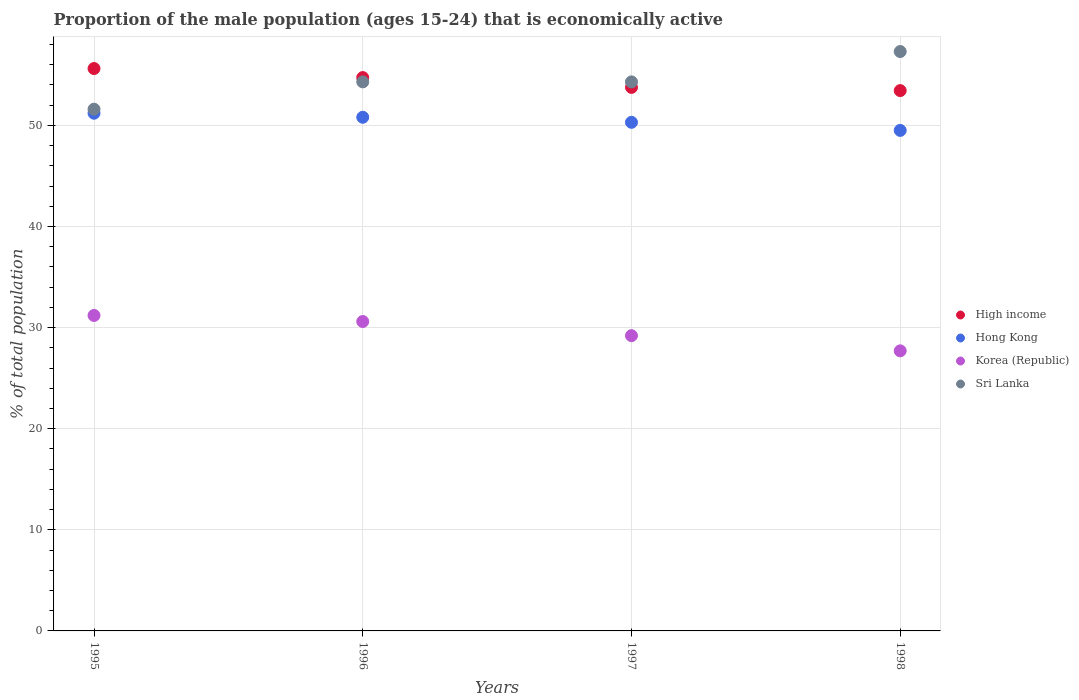What is the proportion of the male population that is economically active in Hong Kong in 1995?
Your response must be concise. 51.2. Across all years, what is the maximum proportion of the male population that is economically active in Sri Lanka?
Offer a terse response. 57.3. Across all years, what is the minimum proportion of the male population that is economically active in Sri Lanka?
Ensure brevity in your answer.  51.6. In which year was the proportion of the male population that is economically active in High income maximum?
Your answer should be very brief. 1995. What is the total proportion of the male population that is economically active in Korea (Republic) in the graph?
Your answer should be very brief. 118.7. What is the difference between the proportion of the male population that is economically active in Hong Kong in 1995 and that in 1998?
Your response must be concise. 1.7. What is the difference between the proportion of the male population that is economically active in Sri Lanka in 1998 and the proportion of the male population that is economically active in Korea (Republic) in 1996?
Your answer should be compact. 26.7. What is the average proportion of the male population that is economically active in Korea (Republic) per year?
Give a very brief answer. 29.68. In the year 1996, what is the difference between the proportion of the male population that is economically active in Korea (Republic) and proportion of the male population that is economically active in Hong Kong?
Offer a terse response. -20.2. In how many years, is the proportion of the male population that is economically active in Korea (Republic) greater than 34 %?
Make the answer very short. 0. What is the ratio of the proportion of the male population that is economically active in Korea (Republic) in 1997 to that in 1998?
Provide a short and direct response. 1.05. Is the proportion of the male population that is economically active in Korea (Republic) in 1995 less than that in 1998?
Offer a terse response. No. What is the difference between the highest and the second highest proportion of the male population that is economically active in High income?
Keep it short and to the point. 0.89. What is the difference between the highest and the lowest proportion of the male population that is economically active in Hong Kong?
Provide a short and direct response. 1.7. In how many years, is the proportion of the male population that is economically active in Hong Kong greater than the average proportion of the male population that is economically active in Hong Kong taken over all years?
Your answer should be compact. 2. Is the sum of the proportion of the male population that is economically active in Korea (Republic) in 1995 and 1996 greater than the maximum proportion of the male population that is economically active in High income across all years?
Offer a very short reply. Yes. Is it the case that in every year, the sum of the proportion of the male population that is economically active in Sri Lanka and proportion of the male population that is economically active in Hong Kong  is greater than the sum of proportion of the male population that is economically active in High income and proportion of the male population that is economically active in Korea (Republic)?
Your answer should be very brief. Yes. Is it the case that in every year, the sum of the proportion of the male population that is economically active in High income and proportion of the male population that is economically active in Sri Lanka  is greater than the proportion of the male population that is economically active in Korea (Republic)?
Offer a terse response. Yes. How many years are there in the graph?
Make the answer very short. 4. What is the difference between two consecutive major ticks on the Y-axis?
Provide a short and direct response. 10. Does the graph contain any zero values?
Offer a terse response. No. Where does the legend appear in the graph?
Offer a terse response. Center right. How many legend labels are there?
Keep it short and to the point. 4. What is the title of the graph?
Give a very brief answer. Proportion of the male population (ages 15-24) that is economically active. What is the label or title of the X-axis?
Offer a very short reply. Years. What is the label or title of the Y-axis?
Your answer should be very brief. % of total population. What is the % of total population of High income in 1995?
Your response must be concise. 55.62. What is the % of total population of Hong Kong in 1995?
Offer a very short reply. 51.2. What is the % of total population in Korea (Republic) in 1995?
Provide a succinct answer. 31.2. What is the % of total population of Sri Lanka in 1995?
Your answer should be compact. 51.6. What is the % of total population of High income in 1996?
Provide a short and direct response. 54.72. What is the % of total population in Hong Kong in 1996?
Make the answer very short. 50.8. What is the % of total population of Korea (Republic) in 1996?
Give a very brief answer. 30.6. What is the % of total population in Sri Lanka in 1996?
Ensure brevity in your answer.  54.3. What is the % of total population of High income in 1997?
Your answer should be very brief. 53.75. What is the % of total population in Hong Kong in 1997?
Provide a succinct answer. 50.3. What is the % of total population of Korea (Republic) in 1997?
Offer a very short reply. 29.2. What is the % of total population of Sri Lanka in 1997?
Offer a terse response. 54.3. What is the % of total population of High income in 1998?
Your answer should be compact. 53.44. What is the % of total population of Hong Kong in 1998?
Keep it short and to the point. 49.5. What is the % of total population in Korea (Republic) in 1998?
Offer a very short reply. 27.7. What is the % of total population in Sri Lanka in 1998?
Your answer should be compact. 57.3. Across all years, what is the maximum % of total population of High income?
Your answer should be very brief. 55.62. Across all years, what is the maximum % of total population in Hong Kong?
Provide a succinct answer. 51.2. Across all years, what is the maximum % of total population in Korea (Republic)?
Provide a succinct answer. 31.2. Across all years, what is the maximum % of total population of Sri Lanka?
Provide a succinct answer. 57.3. Across all years, what is the minimum % of total population of High income?
Offer a very short reply. 53.44. Across all years, what is the minimum % of total population in Hong Kong?
Your response must be concise. 49.5. Across all years, what is the minimum % of total population in Korea (Republic)?
Make the answer very short. 27.7. Across all years, what is the minimum % of total population of Sri Lanka?
Make the answer very short. 51.6. What is the total % of total population in High income in the graph?
Your answer should be very brief. 217.53. What is the total % of total population of Hong Kong in the graph?
Keep it short and to the point. 201.8. What is the total % of total population in Korea (Republic) in the graph?
Give a very brief answer. 118.7. What is the total % of total population in Sri Lanka in the graph?
Keep it short and to the point. 217.5. What is the difference between the % of total population of High income in 1995 and that in 1996?
Keep it short and to the point. 0.89. What is the difference between the % of total population of Korea (Republic) in 1995 and that in 1996?
Give a very brief answer. 0.6. What is the difference between the % of total population in Sri Lanka in 1995 and that in 1996?
Offer a terse response. -2.7. What is the difference between the % of total population in High income in 1995 and that in 1997?
Offer a terse response. 1.87. What is the difference between the % of total population in Hong Kong in 1995 and that in 1997?
Your response must be concise. 0.9. What is the difference between the % of total population of High income in 1995 and that in 1998?
Offer a terse response. 2.18. What is the difference between the % of total population in Hong Kong in 1995 and that in 1998?
Offer a terse response. 1.7. What is the difference between the % of total population of Sri Lanka in 1995 and that in 1998?
Make the answer very short. -5.7. What is the difference between the % of total population in High income in 1996 and that in 1997?
Offer a very short reply. 0.97. What is the difference between the % of total population in Hong Kong in 1996 and that in 1997?
Your answer should be compact. 0.5. What is the difference between the % of total population of Korea (Republic) in 1996 and that in 1997?
Offer a very short reply. 1.4. What is the difference between the % of total population in Sri Lanka in 1996 and that in 1997?
Provide a succinct answer. 0. What is the difference between the % of total population of High income in 1996 and that in 1998?
Ensure brevity in your answer.  1.29. What is the difference between the % of total population in High income in 1997 and that in 1998?
Provide a short and direct response. 0.32. What is the difference between the % of total population in Korea (Republic) in 1997 and that in 1998?
Provide a short and direct response. 1.5. What is the difference between the % of total population in High income in 1995 and the % of total population in Hong Kong in 1996?
Give a very brief answer. 4.82. What is the difference between the % of total population in High income in 1995 and the % of total population in Korea (Republic) in 1996?
Give a very brief answer. 25.02. What is the difference between the % of total population in High income in 1995 and the % of total population in Sri Lanka in 1996?
Make the answer very short. 1.32. What is the difference between the % of total population of Hong Kong in 1995 and the % of total population of Korea (Republic) in 1996?
Offer a terse response. 20.6. What is the difference between the % of total population in Hong Kong in 1995 and the % of total population in Sri Lanka in 1996?
Your response must be concise. -3.1. What is the difference between the % of total population of Korea (Republic) in 1995 and the % of total population of Sri Lanka in 1996?
Your answer should be very brief. -23.1. What is the difference between the % of total population in High income in 1995 and the % of total population in Hong Kong in 1997?
Your answer should be compact. 5.32. What is the difference between the % of total population of High income in 1995 and the % of total population of Korea (Republic) in 1997?
Ensure brevity in your answer.  26.42. What is the difference between the % of total population in High income in 1995 and the % of total population in Sri Lanka in 1997?
Make the answer very short. 1.32. What is the difference between the % of total population in Hong Kong in 1995 and the % of total population in Sri Lanka in 1997?
Offer a very short reply. -3.1. What is the difference between the % of total population of Korea (Republic) in 1995 and the % of total population of Sri Lanka in 1997?
Your answer should be compact. -23.1. What is the difference between the % of total population of High income in 1995 and the % of total population of Hong Kong in 1998?
Your answer should be very brief. 6.12. What is the difference between the % of total population in High income in 1995 and the % of total population in Korea (Republic) in 1998?
Keep it short and to the point. 27.92. What is the difference between the % of total population of High income in 1995 and the % of total population of Sri Lanka in 1998?
Offer a very short reply. -1.68. What is the difference between the % of total population of Hong Kong in 1995 and the % of total population of Korea (Republic) in 1998?
Ensure brevity in your answer.  23.5. What is the difference between the % of total population in Hong Kong in 1995 and the % of total population in Sri Lanka in 1998?
Offer a terse response. -6.1. What is the difference between the % of total population of Korea (Republic) in 1995 and the % of total population of Sri Lanka in 1998?
Offer a terse response. -26.1. What is the difference between the % of total population of High income in 1996 and the % of total population of Hong Kong in 1997?
Your response must be concise. 4.42. What is the difference between the % of total population of High income in 1996 and the % of total population of Korea (Republic) in 1997?
Provide a short and direct response. 25.52. What is the difference between the % of total population of High income in 1996 and the % of total population of Sri Lanka in 1997?
Give a very brief answer. 0.42. What is the difference between the % of total population of Hong Kong in 1996 and the % of total population of Korea (Republic) in 1997?
Keep it short and to the point. 21.6. What is the difference between the % of total population in Hong Kong in 1996 and the % of total population in Sri Lanka in 1997?
Your response must be concise. -3.5. What is the difference between the % of total population in Korea (Republic) in 1996 and the % of total population in Sri Lanka in 1997?
Ensure brevity in your answer.  -23.7. What is the difference between the % of total population of High income in 1996 and the % of total population of Hong Kong in 1998?
Offer a very short reply. 5.22. What is the difference between the % of total population in High income in 1996 and the % of total population in Korea (Republic) in 1998?
Ensure brevity in your answer.  27.02. What is the difference between the % of total population of High income in 1996 and the % of total population of Sri Lanka in 1998?
Give a very brief answer. -2.58. What is the difference between the % of total population of Hong Kong in 1996 and the % of total population of Korea (Republic) in 1998?
Offer a terse response. 23.1. What is the difference between the % of total population in Hong Kong in 1996 and the % of total population in Sri Lanka in 1998?
Provide a succinct answer. -6.5. What is the difference between the % of total population in Korea (Republic) in 1996 and the % of total population in Sri Lanka in 1998?
Give a very brief answer. -26.7. What is the difference between the % of total population of High income in 1997 and the % of total population of Hong Kong in 1998?
Provide a short and direct response. 4.25. What is the difference between the % of total population of High income in 1997 and the % of total population of Korea (Republic) in 1998?
Keep it short and to the point. 26.05. What is the difference between the % of total population of High income in 1997 and the % of total population of Sri Lanka in 1998?
Make the answer very short. -3.55. What is the difference between the % of total population of Hong Kong in 1997 and the % of total population of Korea (Republic) in 1998?
Provide a short and direct response. 22.6. What is the difference between the % of total population of Hong Kong in 1997 and the % of total population of Sri Lanka in 1998?
Make the answer very short. -7. What is the difference between the % of total population in Korea (Republic) in 1997 and the % of total population in Sri Lanka in 1998?
Keep it short and to the point. -28.1. What is the average % of total population of High income per year?
Provide a succinct answer. 54.38. What is the average % of total population of Hong Kong per year?
Your answer should be very brief. 50.45. What is the average % of total population in Korea (Republic) per year?
Your response must be concise. 29.68. What is the average % of total population of Sri Lanka per year?
Give a very brief answer. 54.38. In the year 1995, what is the difference between the % of total population of High income and % of total population of Hong Kong?
Your answer should be very brief. 4.42. In the year 1995, what is the difference between the % of total population of High income and % of total population of Korea (Republic)?
Keep it short and to the point. 24.42. In the year 1995, what is the difference between the % of total population in High income and % of total population in Sri Lanka?
Your answer should be compact. 4.02. In the year 1995, what is the difference between the % of total population of Hong Kong and % of total population of Korea (Republic)?
Provide a succinct answer. 20. In the year 1995, what is the difference between the % of total population of Hong Kong and % of total population of Sri Lanka?
Keep it short and to the point. -0.4. In the year 1995, what is the difference between the % of total population of Korea (Republic) and % of total population of Sri Lanka?
Your answer should be compact. -20.4. In the year 1996, what is the difference between the % of total population of High income and % of total population of Hong Kong?
Ensure brevity in your answer.  3.92. In the year 1996, what is the difference between the % of total population in High income and % of total population in Korea (Republic)?
Your answer should be very brief. 24.12. In the year 1996, what is the difference between the % of total population in High income and % of total population in Sri Lanka?
Give a very brief answer. 0.42. In the year 1996, what is the difference between the % of total population of Hong Kong and % of total population of Korea (Republic)?
Keep it short and to the point. 20.2. In the year 1996, what is the difference between the % of total population of Hong Kong and % of total population of Sri Lanka?
Your answer should be very brief. -3.5. In the year 1996, what is the difference between the % of total population of Korea (Republic) and % of total population of Sri Lanka?
Keep it short and to the point. -23.7. In the year 1997, what is the difference between the % of total population in High income and % of total population in Hong Kong?
Ensure brevity in your answer.  3.45. In the year 1997, what is the difference between the % of total population in High income and % of total population in Korea (Republic)?
Your response must be concise. 24.55. In the year 1997, what is the difference between the % of total population in High income and % of total population in Sri Lanka?
Offer a terse response. -0.55. In the year 1997, what is the difference between the % of total population in Hong Kong and % of total population in Korea (Republic)?
Provide a short and direct response. 21.1. In the year 1997, what is the difference between the % of total population in Korea (Republic) and % of total population in Sri Lanka?
Keep it short and to the point. -25.1. In the year 1998, what is the difference between the % of total population in High income and % of total population in Hong Kong?
Give a very brief answer. 3.94. In the year 1998, what is the difference between the % of total population in High income and % of total population in Korea (Republic)?
Ensure brevity in your answer.  25.74. In the year 1998, what is the difference between the % of total population in High income and % of total population in Sri Lanka?
Ensure brevity in your answer.  -3.86. In the year 1998, what is the difference between the % of total population of Hong Kong and % of total population of Korea (Republic)?
Your answer should be very brief. 21.8. In the year 1998, what is the difference between the % of total population of Korea (Republic) and % of total population of Sri Lanka?
Ensure brevity in your answer.  -29.6. What is the ratio of the % of total population in High income in 1995 to that in 1996?
Provide a succinct answer. 1.02. What is the ratio of the % of total population of Hong Kong in 1995 to that in 1996?
Your answer should be compact. 1.01. What is the ratio of the % of total population of Korea (Republic) in 1995 to that in 1996?
Your answer should be very brief. 1.02. What is the ratio of the % of total population of Sri Lanka in 1995 to that in 1996?
Your answer should be compact. 0.95. What is the ratio of the % of total population in High income in 1995 to that in 1997?
Offer a very short reply. 1.03. What is the ratio of the % of total population in Hong Kong in 1995 to that in 1997?
Provide a short and direct response. 1.02. What is the ratio of the % of total population in Korea (Republic) in 1995 to that in 1997?
Make the answer very short. 1.07. What is the ratio of the % of total population in Sri Lanka in 1995 to that in 1997?
Offer a terse response. 0.95. What is the ratio of the % of total population of High income in 1995 to that in 1998?
Your response must be concise. 1.04. What is the ratio of the % of total population in Hong Kong in 1995 to that in 1998?
Provide a succinct answer. 1.03. What is the ratio of the % of total population in Korea (Republic) in 1995 to that in 1998?
Your response must be concise. 1.13. What is the ratio of the % of total population of Sri Lanka in 1995 to that in 1998?
Offer a terse response. 0.9. What is the ratio of the % of total population of High income in 1996 to that in 1997?
Offer a terse response. 1.02. What is the ratio of the % of total population in Hong Kong in 1996 to that in 1997?
Give a very brief answer. 1.01. What is the ratio of the % of total population in Korea (Republic) in 1996 to that in 1997?
Your answer should be compact. 1.05. What is the ratio of the % of total population in Sri Lanka in 1996 to that in 1997?
Offer a terse response. 1. What is the ratio of the % of total population of High income in 1996 to that in 1998?
Make the answer very short. 1.02. What is the ratio of the % of total population in Hong Kong in 1996 to that in 1998?
Give a very brief answer. 1.03. What is the ratio of the % of total population of Korea (Republic) in 1996 to that in 1998?
Offer a terse response. 1.1. What is the ratio of the % of total population of Sri Lanka in 1996 to that in 1998?
Your answer should be very brief. 0.95. What is the ratio of the % of total population of High income in 1997 to that in 1998?
Keep it short and to the point. 1.01. What is the ratio of the % of total population of Hong Kong in 1997 to that in 1998?
Offer a terse response. 1.02. What is the ratio of the % of total population of Korea (Republic) in 1997 to that in 1998?
Make the answer very short. 1.05. What is the ratio of the % of total population in Sri Lanka in 1997 to that in 1998?
Your response must be concise. 0.95. What is the difference between the highest and the second highest % of total population in High income?
Give a very brief answer. 0.89. What is the difference between the highest and the second highest % of total population of Hong Kong?
Ensure brevity in your answer.  0.4. What is the difference between the highest and the lowest % of total population in High income?
Your answer should be very brief. 2.18. What is the difference between the highest and the lowest % of total population of Hong Kong?
Provide a short and direct response. 1.7. What is the difference between the highest and the lowest % of total population in Sri Lanka?
Keep it short and to the point. 5.7. 